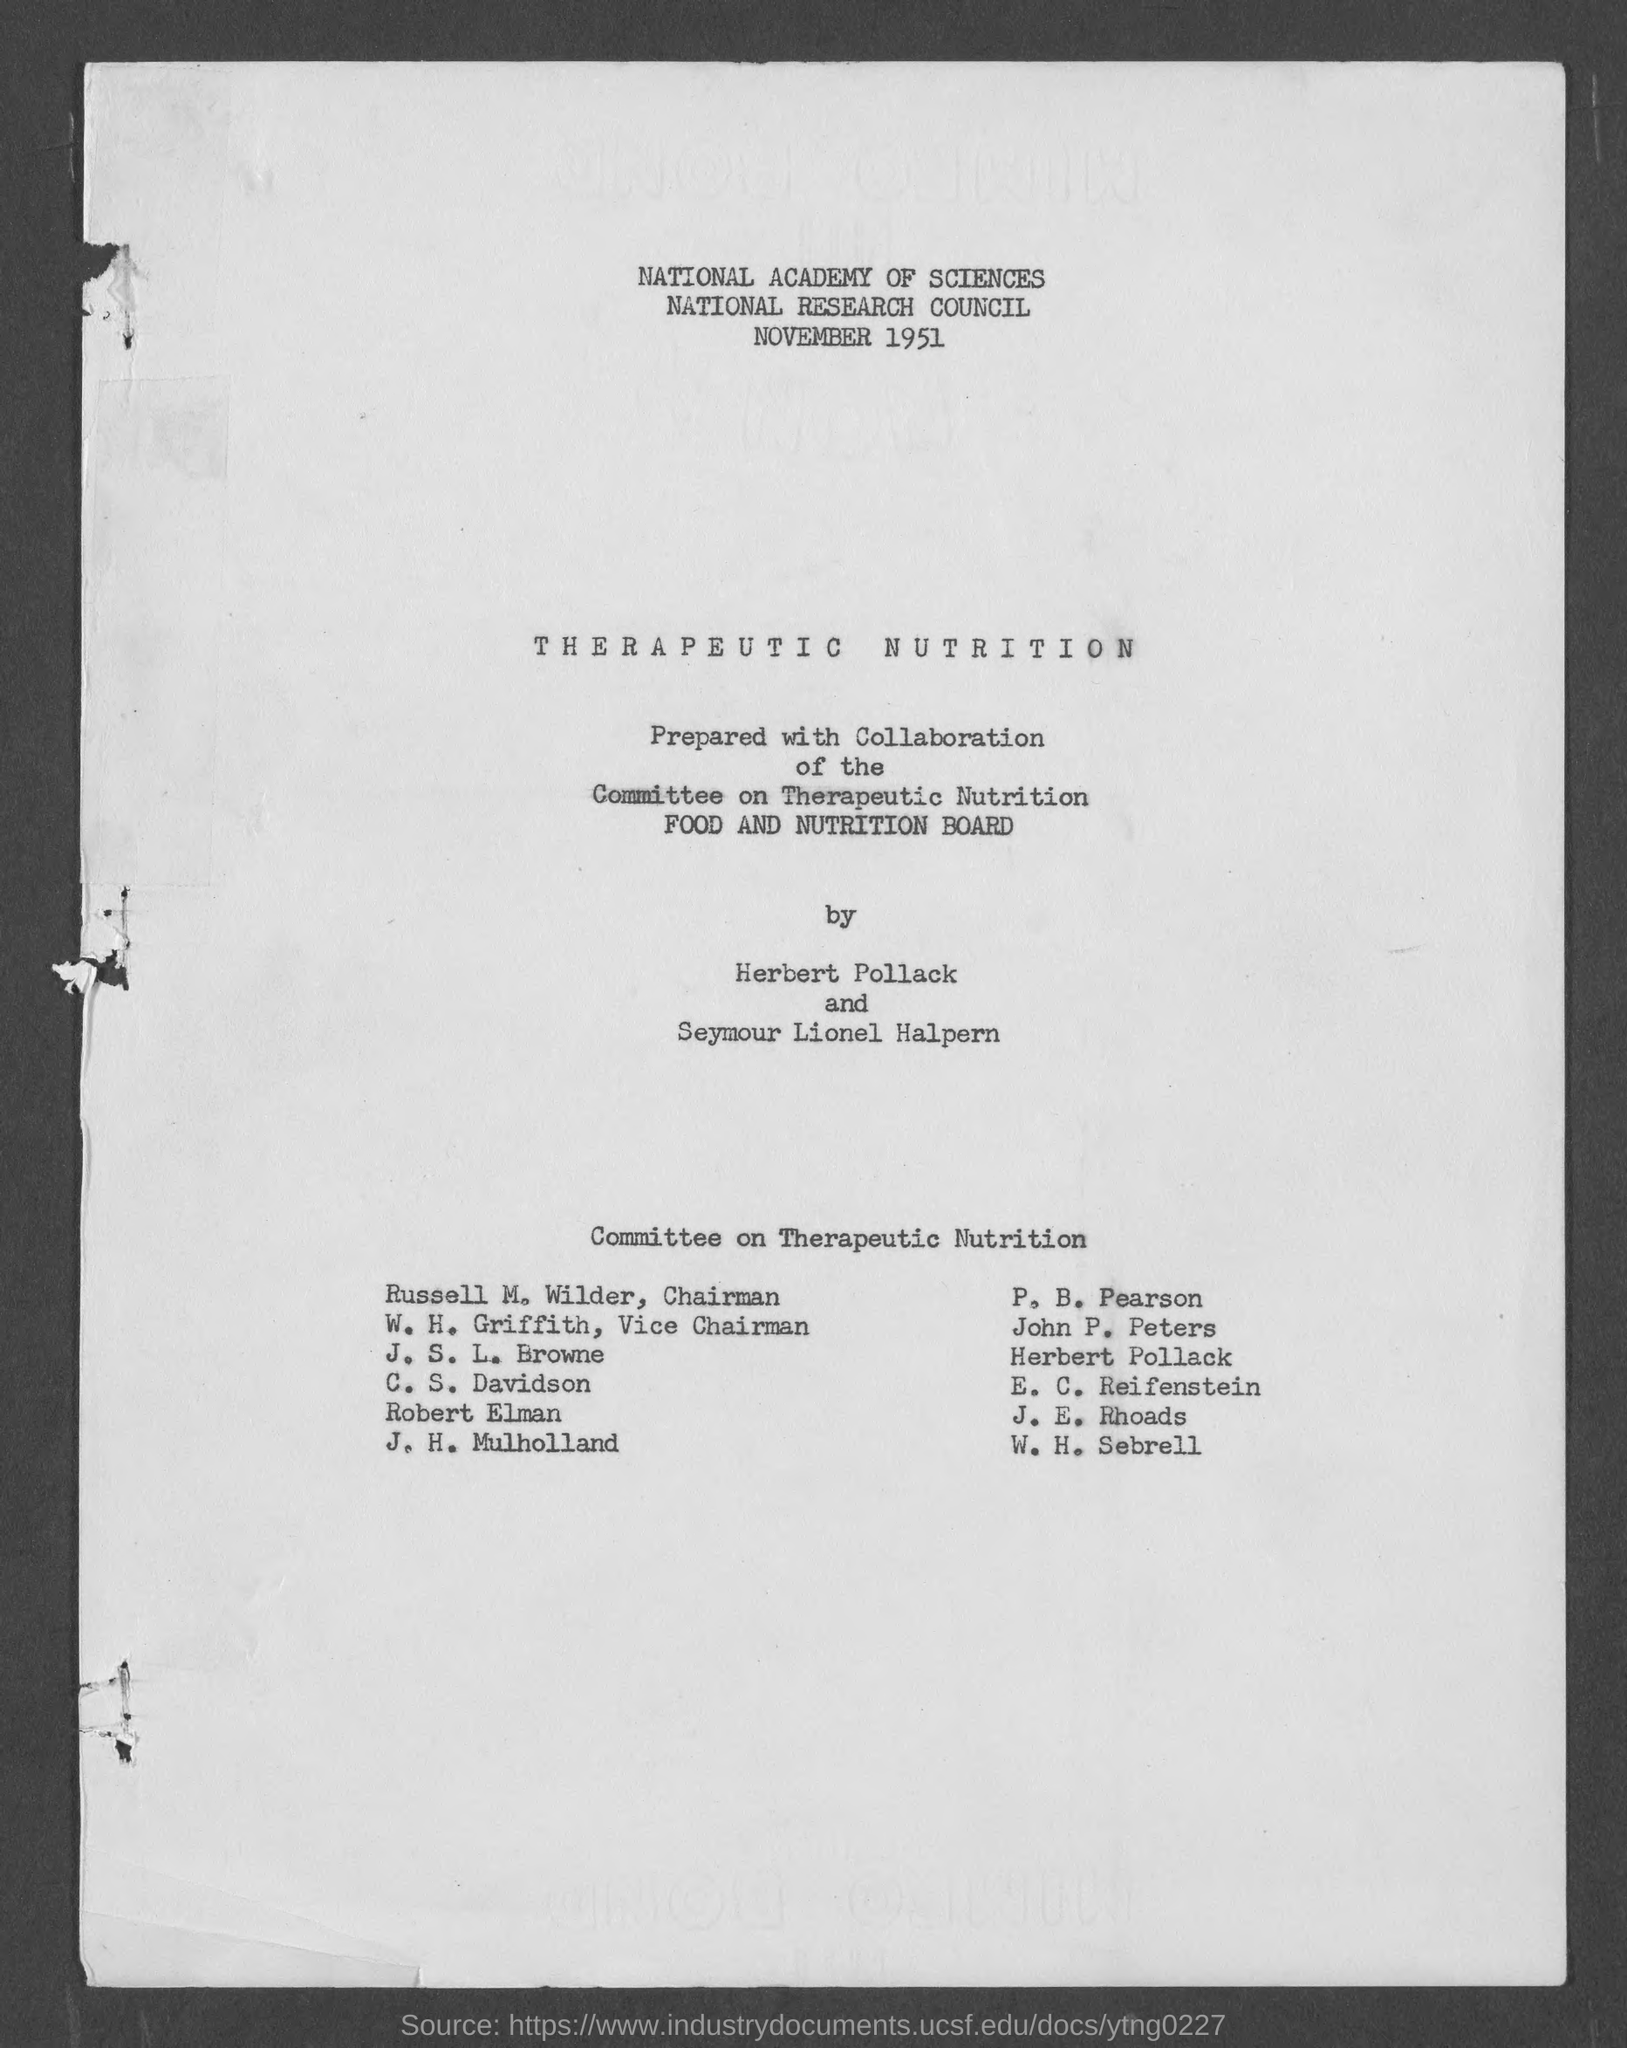Who is the chairman, committee on therapeutic nutrition ?
Offer a very short reply. Russell M. Wilder. 